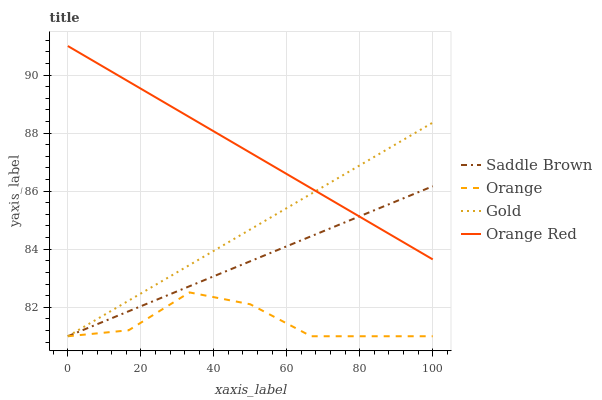Does Orange have the minimum area under the curve?
Answer yes or no. Yes. Does Orange Red have the maximum area under the curve?
Answer yes or no. Yes. Does Saddle Brown have the minimum area under the curve?
Answer yes or no. No. Does Saddle Brown have the maximum area under the curve?
Answer yes or no. No. Is Saddle Brown the smoothest?
Answer yes or no. Yes. Is Orange the roughest?
Answer yes or no. Yes. Is Gold the smoothest?
Answer yes or no. No. Is Gold the roughest?
Answer yes or no. No. Does Orange have the lowest value?
Answer yes or no. Yes. Does Orange Red have the lowest value?
Answer yes or no. No. Does Orange Red have the highest value?
Answer yes or no. Yes. Does Saddle Brown have the highest value?
Answer yes or no. No. Is Orange less than Orange Red?
Answer yes or no. Yes. Is Orange Red greater than Orange?
Answer yes or no. Yes. Does Gold intersect Orange Red?
Answer yes or no. Yes. Is Gold less than Orange Red?
Answer yes or no. No. Is Gold greater than Orange Red?
Answer yes or no. No. Does Orange intersect Orange Red?
Answer yes or no. No. 